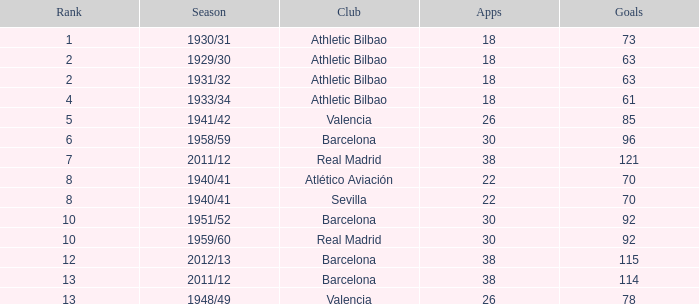How many apps when the rank was after 13 and having more than 73 goals? None. I'm looking to parse the entire table for insights. Could you assist me with that? {'header': ['Rank', 'Season', 'Club', 'Apps', 'Goals'], 'rows': [['1', '1930/31', 'Athletic Bilbao', '18', '73'], ['2', '1929/30', 'Athletic Bilbao', '18', '63'], ['2', '1931/32', 'Athletic Bilbao', '18', '63'], ['4', '1933/34', 'Athletic Bilbao', '18', '61'], ['5', '1941/42', 'Valencia', '26', '85'], ['6', '1958/59', 'Barcelona', '30', '96'], ['7', '2011/12', 'Real Madrid', '38', '121'], ['8', '1940/41', 'Atlético Aviación', '22', '70'], ['8', '1940/41', 'Sevilla', '22', '70'], ['10', '1951/52', 'Barcelona', '30', '92'], ['10', '1959/60', 'Real Madrid', '30', '92'], ['12', '2012/13', 'Barcelona', '38', '115'], ['13', '2011/12', 'Barcelona', '38', '114'], ['13', '1948/49', 'Valencia', '26', '78']]} 